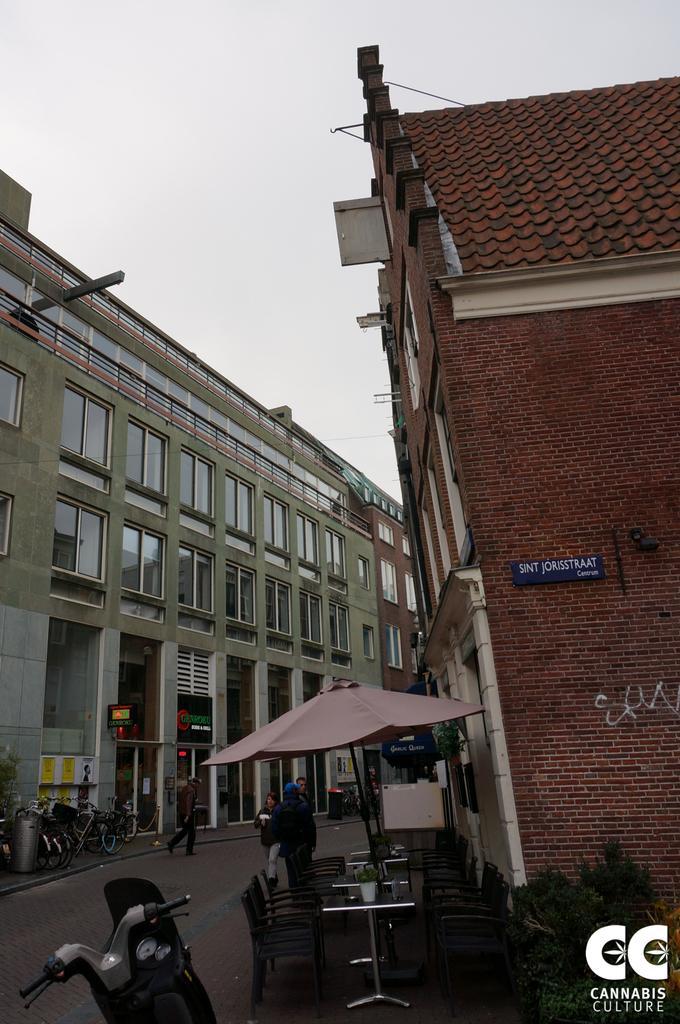Please provide a concise description of this image. In this image we can see few buildings and there are few people in the street and we can see some bicycles and a bike. There are few plants and we can see some chairs and tables under the umbrella and at the top we can see the sky. 